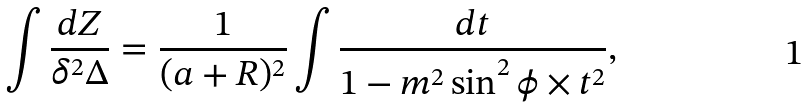Convert formula to latex. <formula><loc_0><loc_0><loc_500><loc_500>\int \frac { d Z } { \delta ^ { 2 } \Delta } & = \frac { 1 } { ( a + R ) ^ { 2 } } \int { \frac { d t } { 1 - m ^ { 2 } \sin ^ { 2 } \phi \times t ^ { 2 } } } ,</formula> 